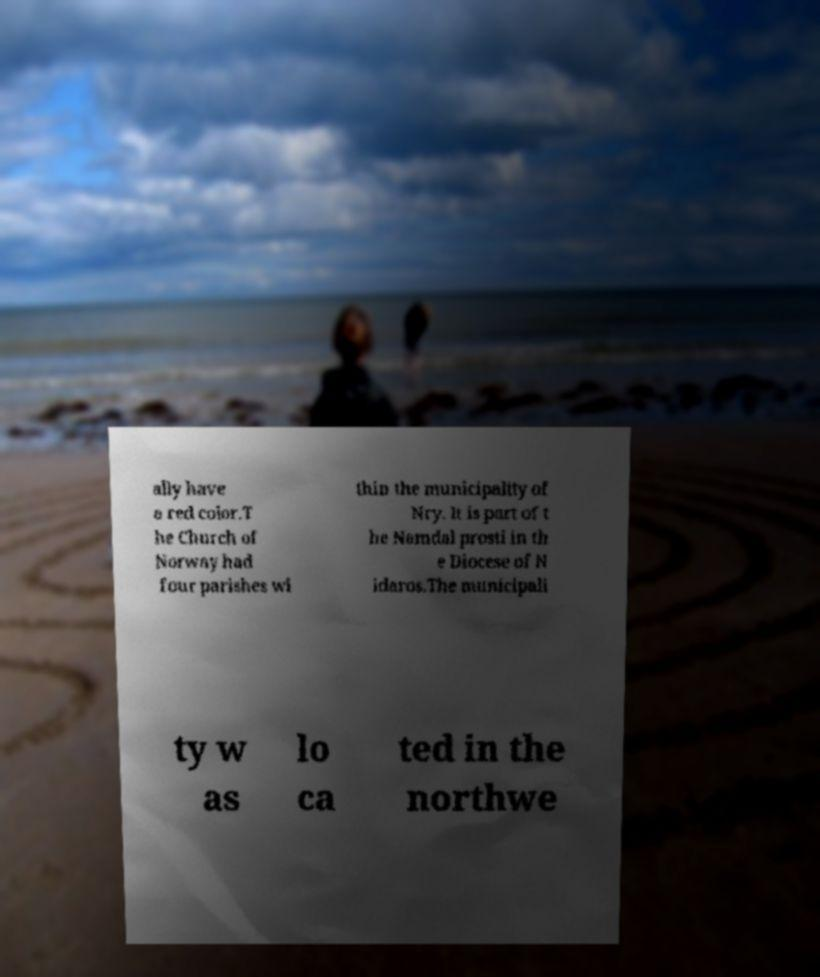Please read and relay the text visible in this image. What does it say? ally have a red color.T he Church of Norway had four parishes wi thin the municipality of Nry. It is part of t he Namdal prosti in th e Diocese of N idaros.The municipali ty w as lo ca ted in the northwe 